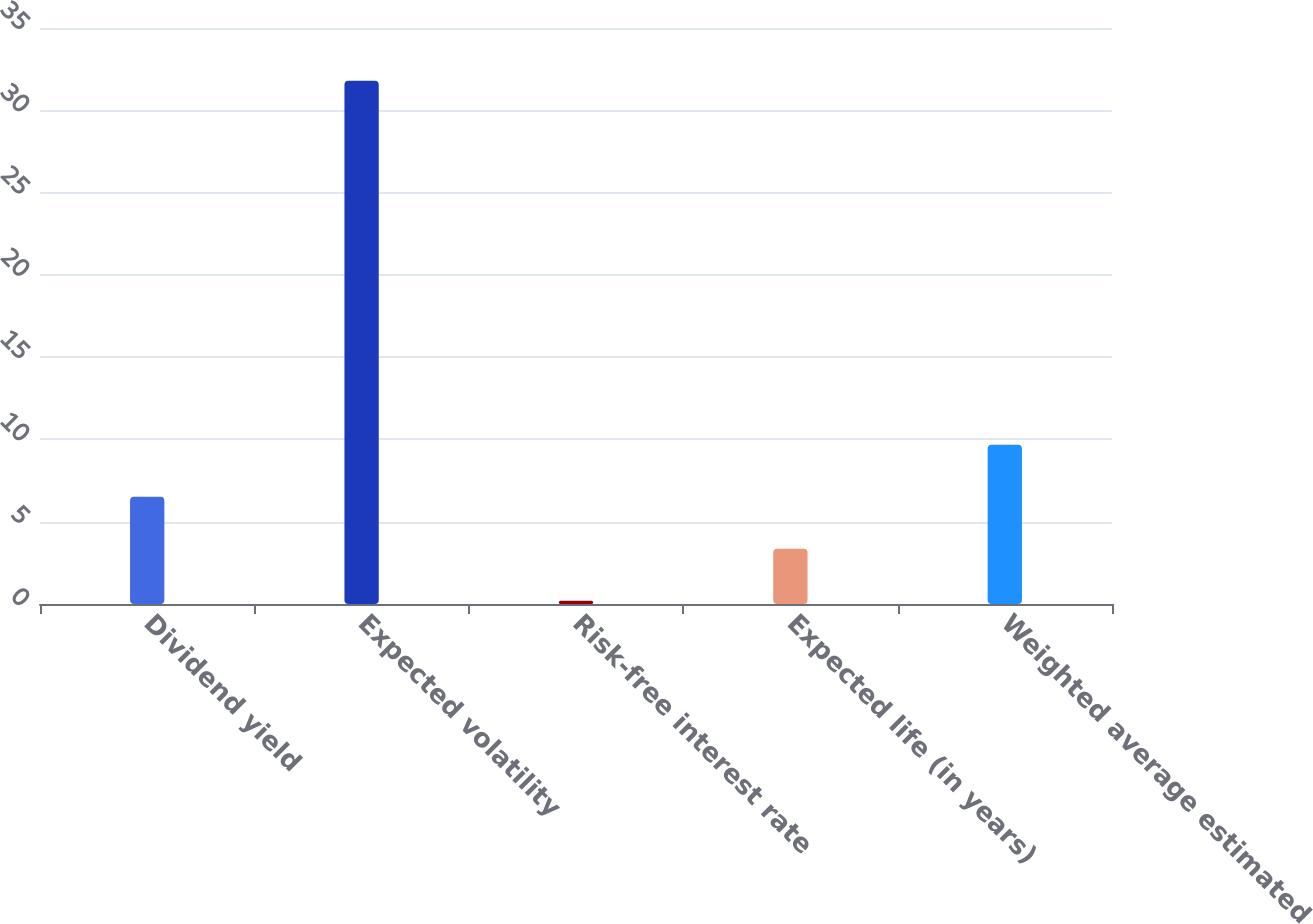<chart> <loc_0><loc_0><loc_500><loc_500><bar_chart><fcel>Dividend yield<fcel>Expected volatility<fcel>Risk-free interest rate<fcel>Expected life (in years)<fcel>Weighted average estimated<nl><fcel>6.51<fcel>31.8<fcel>0.19<fcel>3.35<fcel>9.67<nl></chart> 